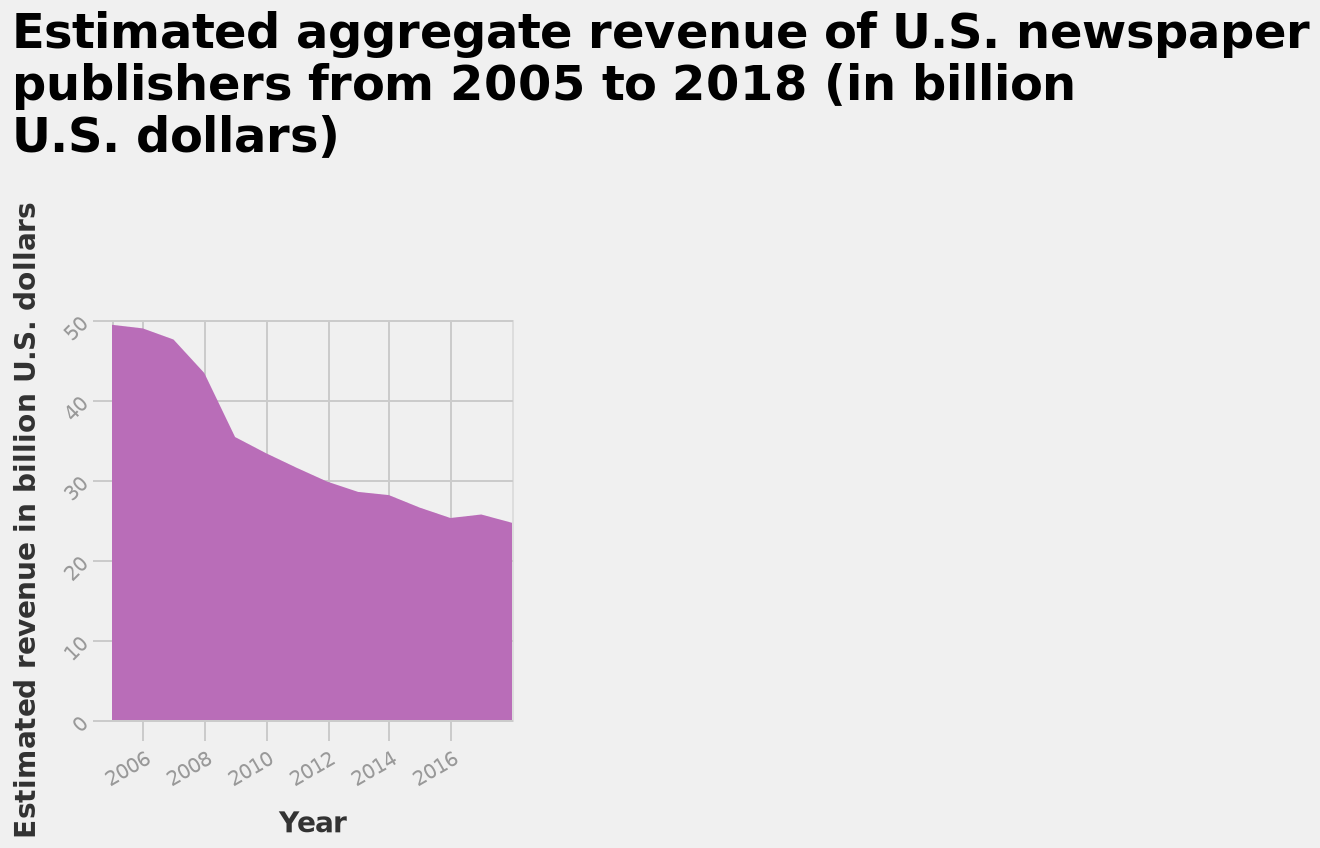<image>
In which currency is the estimated aggregate revenue measured? The estimated aggregate revenue is measured in billion U.S. dollars. Is the estimated aggregate revenue measured in billion Indian rupees? No.The estimated aggregate revenue is measured in billion U.S. dollars. 